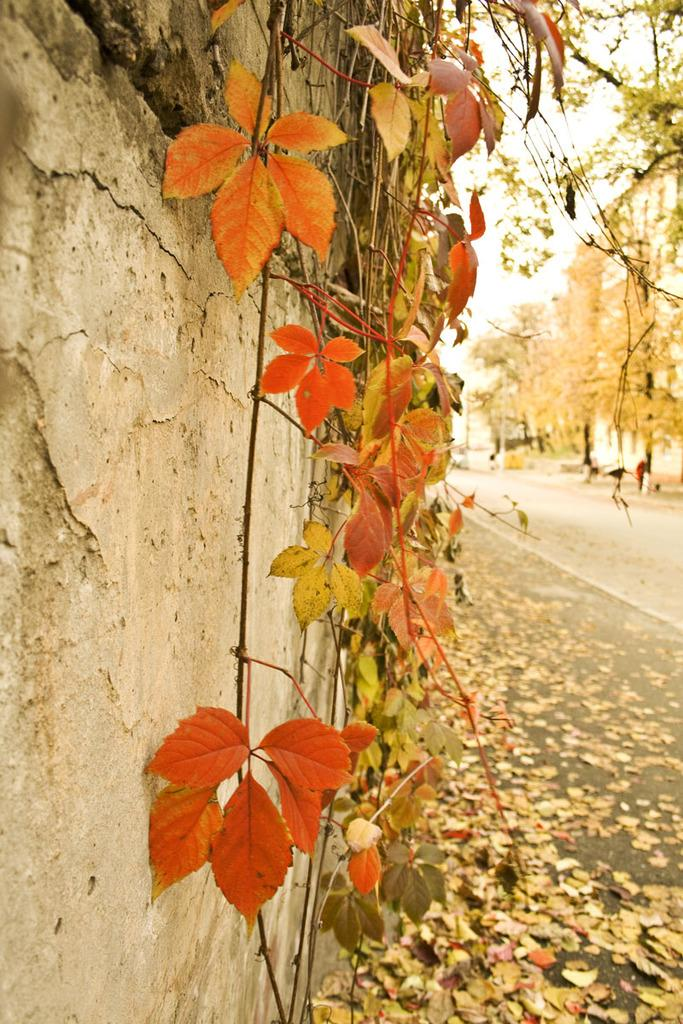What is located on the left side of the image? There is a wall on the left side of the image, along with leaves and branches. What can be seen on the right side of the image? There are trees and a road on the right side of the image, with dried leaves visible above the road. How does the peace symbol appear in the image? There is no peace symbol present in the image. What type of bun can be seen in the image? There is no bun present in the image. 